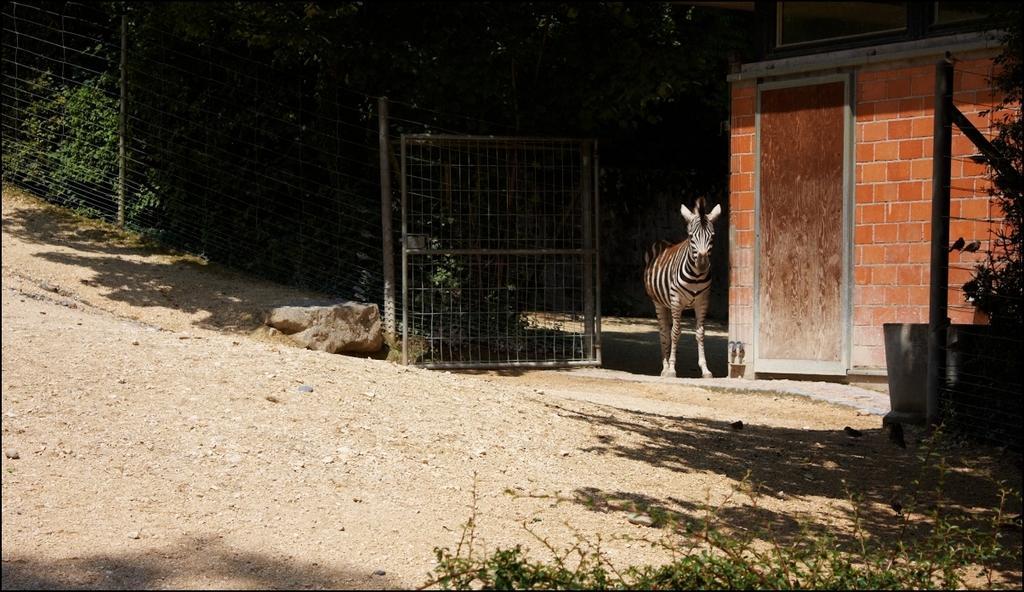Can you describe this image briefly? In this image we can see a zebra, there are some plants and trees, also we can see a house, a fence, gate, pole, and a door, there are rocks. 